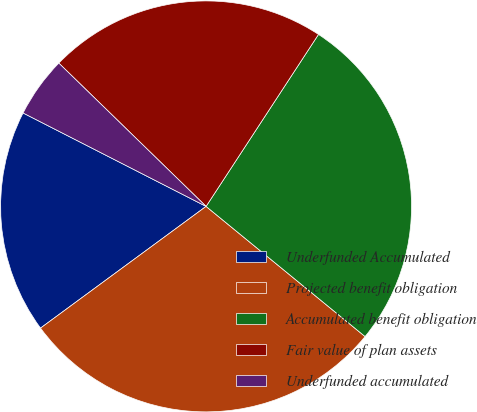<chart> <loc_0><loc_0><loc_500><loc_500><pie_chart><fcel>Underfunded Accumulated<fcel>Projected benefit obligation<fcel>Accumulated benefit obligation<fcel>Fair value of plan assets<fcel>Underfunded accumulated<nl><fcel>17.6%<fcel>28.99%<fcel>26.7%<fcel>21.93%<fcel>4.77%<nl></chart> 